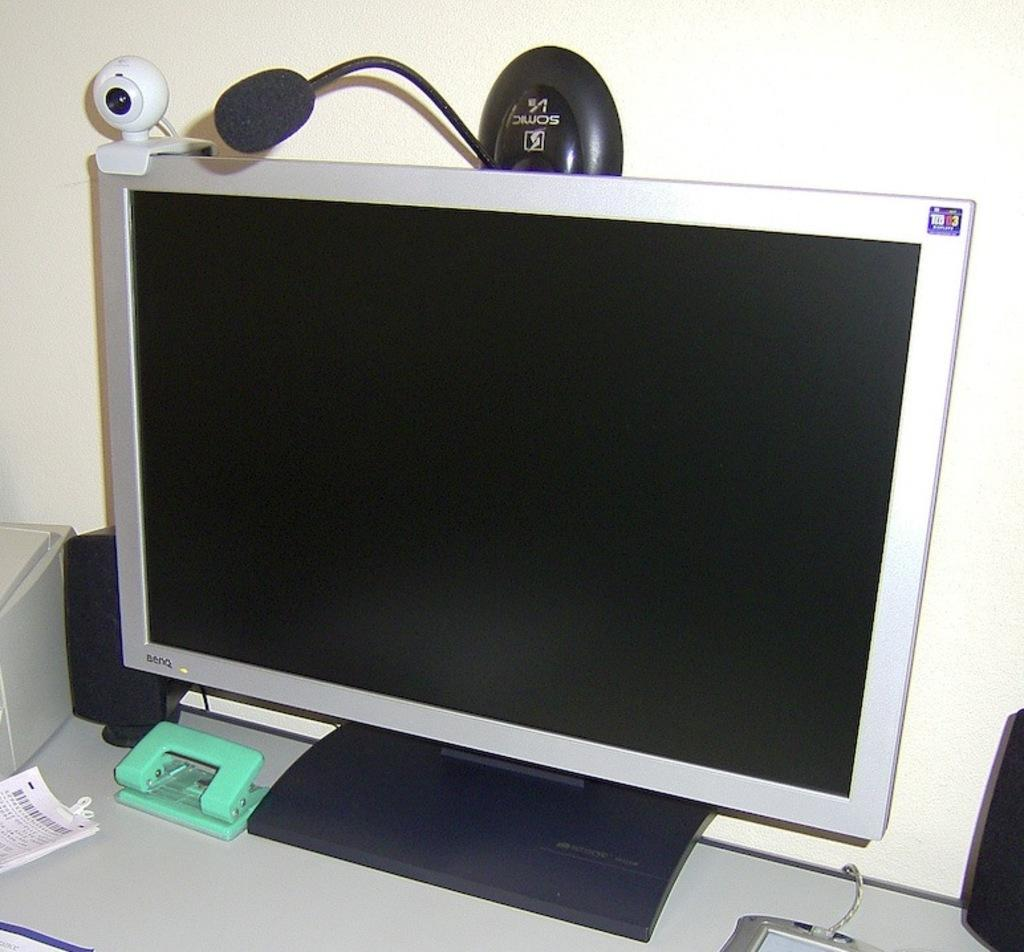<image>
Summarize the visual content of the image. A BENQ monitor sits on a desk with a webcam 